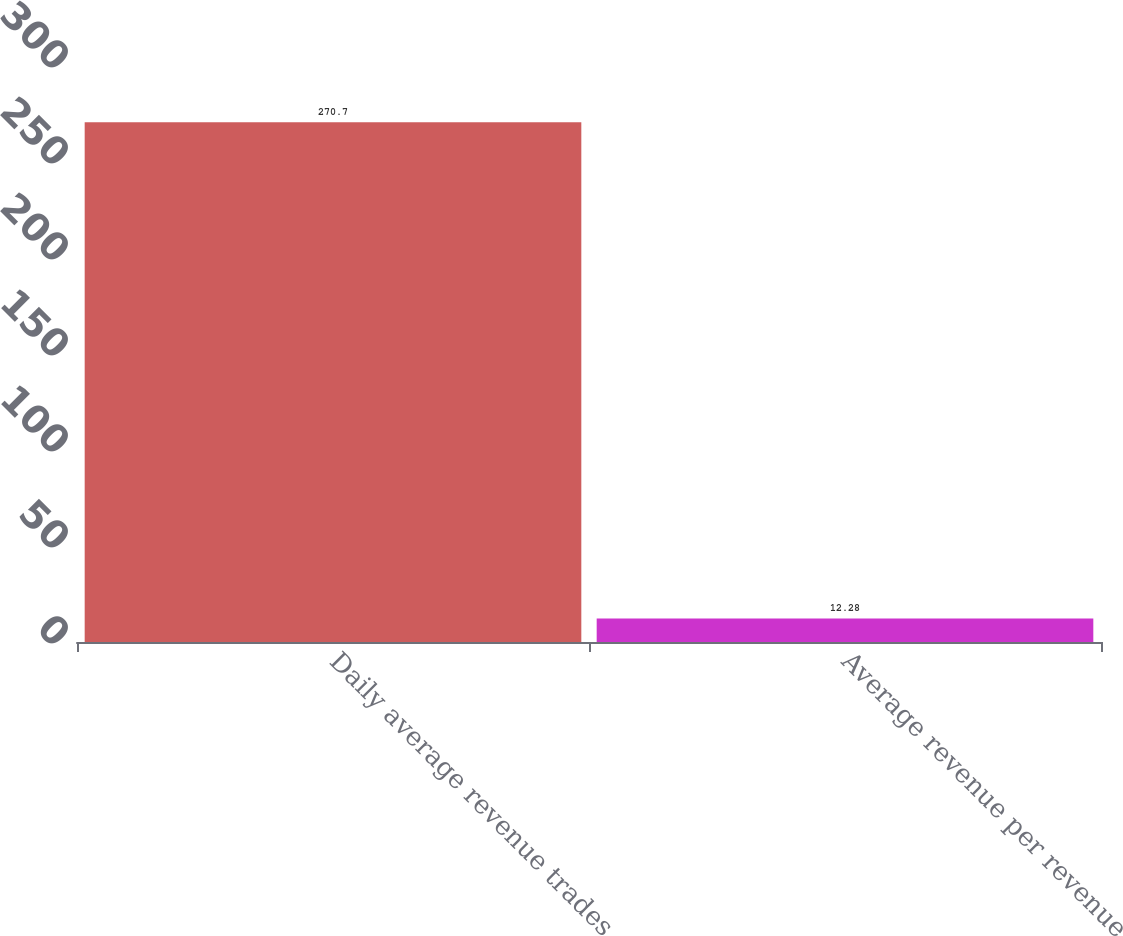<chart> <loc_0><loc_0><loc_500><loc_500><bar_chart><fcel>Daily average revenue trades<fcel>Average revenue per revenue<nl><fcel>270.7<fcel>12.28<nl></chart> 